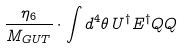Convert formula to latex. <formula><loc_0><loc_0><loc_500><loc_500>\frac { \eta _ { 6 } } { M _ { G U T } } \cdot \int d ^ { 4 } \theta \, U ^ { \dag } E ^ { \dag } Q Q</formula> 